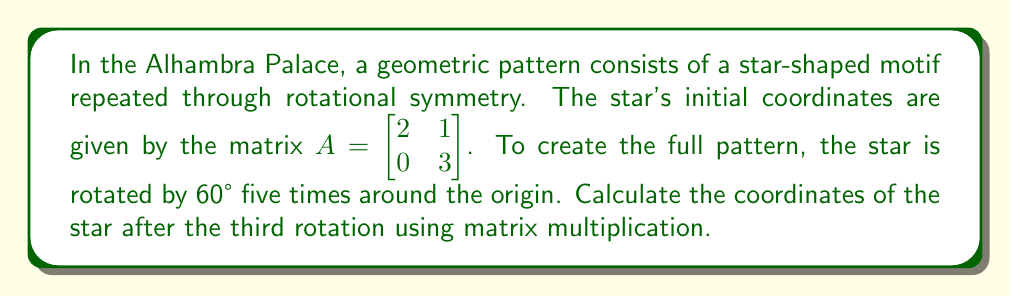Give your solution to this math problem. To solve this problem, we'll follow these steps:

1) First, we need to create a rotation matrix for 60°. The rotation matrix for an angle $\theta$ is given by:

   $$R(\theta) = \begin{bmatrix} \cos\theta & -\sin\theta \\ \sin\theta & \cos\theta \end{bmatrix}$$

   For 60°, or $\frac{\pi}{3}$ radians:

   $$R(60°) = \begin{bmatrix} \cos(\frac{\pi}{3}) & -\sin(\frac{\pi}{3}) \\ \sin(\frac{\pi}{3}) & \cos(\frac{\pi}{3}) \end{bmatrix} = \begin{bmatrix} \frac{1}{2} & -\frac{\sqrt{3}}{2} \\ \frac{\sqrt{3}}{2} & \frac{1}{2} \end{bmatrix}$$

2) To rotate the star three times, we need to apply this rotation matrix three times:

   $$A_3 = R(60°) \cdot R(60°) \cdot R(60°) \cdot A$$

3) Let's calculate $R(60°)^3$:

   $$R(60°)^3 = \begin{bmatrix} \frac{1}{2} & -\frac{\sqrt{3}}{2} \\ \frac{\sqrt{3}}{2} & \frac{1}{2} \end{bmatrix}^3 = \begin{bmatrix} -\frac{1}{2} & -\frac{\sqrt{3}}{2} \\ \frac{\sqrt{3}}{2} & -\frac{1}{2} \end{bmatrix}$$

4) Now, we multiply this result with the initial coordinates:

   $$A_3 = \begin{bmatrix} -\frac{1}{2} & -\frac{\sqrt{3}}{2} \\ \frac{\sqrt{3}}{2} & -\frac{1}{2} \end{bmatrix} \cdot \begin{bmatrix} 2 & 1 \\ 0 & 3 \end{bmatrix}$$

5) Performing the matrix multiplication:

   $$A_3 = \begin{bmatrix} (-\frac{1}{2} \cdot 2 + -\frac{\sqrt{3}}{2} \cdot 0) & (-\frac{1}{2} \cdot 1 + -\frac{\sqrt{3}}{2} \cdot 3) \\ (\frac{\sqrt{3}}{2} \cdot 2 + -\frac{1}{2} \cdot 0) & (\frac{\sqrt{3}}{2} \cdot 1 + -\frac{1}{2} \cdot 3) \end{bmatrix}$$

6) Simplifying:

   $$A_3 = \begin{bmatrix} -1 & -\frac{1}{2} - \frac{3\sqrt{3}}{2} \\ \sqrt{3} & \frac{\sqrt{3}}{2} - \frac{3}{2} \end{bmatrix}$$
Answer: $$\begin{bmatrix} -1 & -\frac{1}{2} - \frac{3\sqrt{3}}{2} \\ \sqrt{3} & \frac{\sqrt{3}}{2} - \frac{3}{2} \end{bmatrix}$$ 